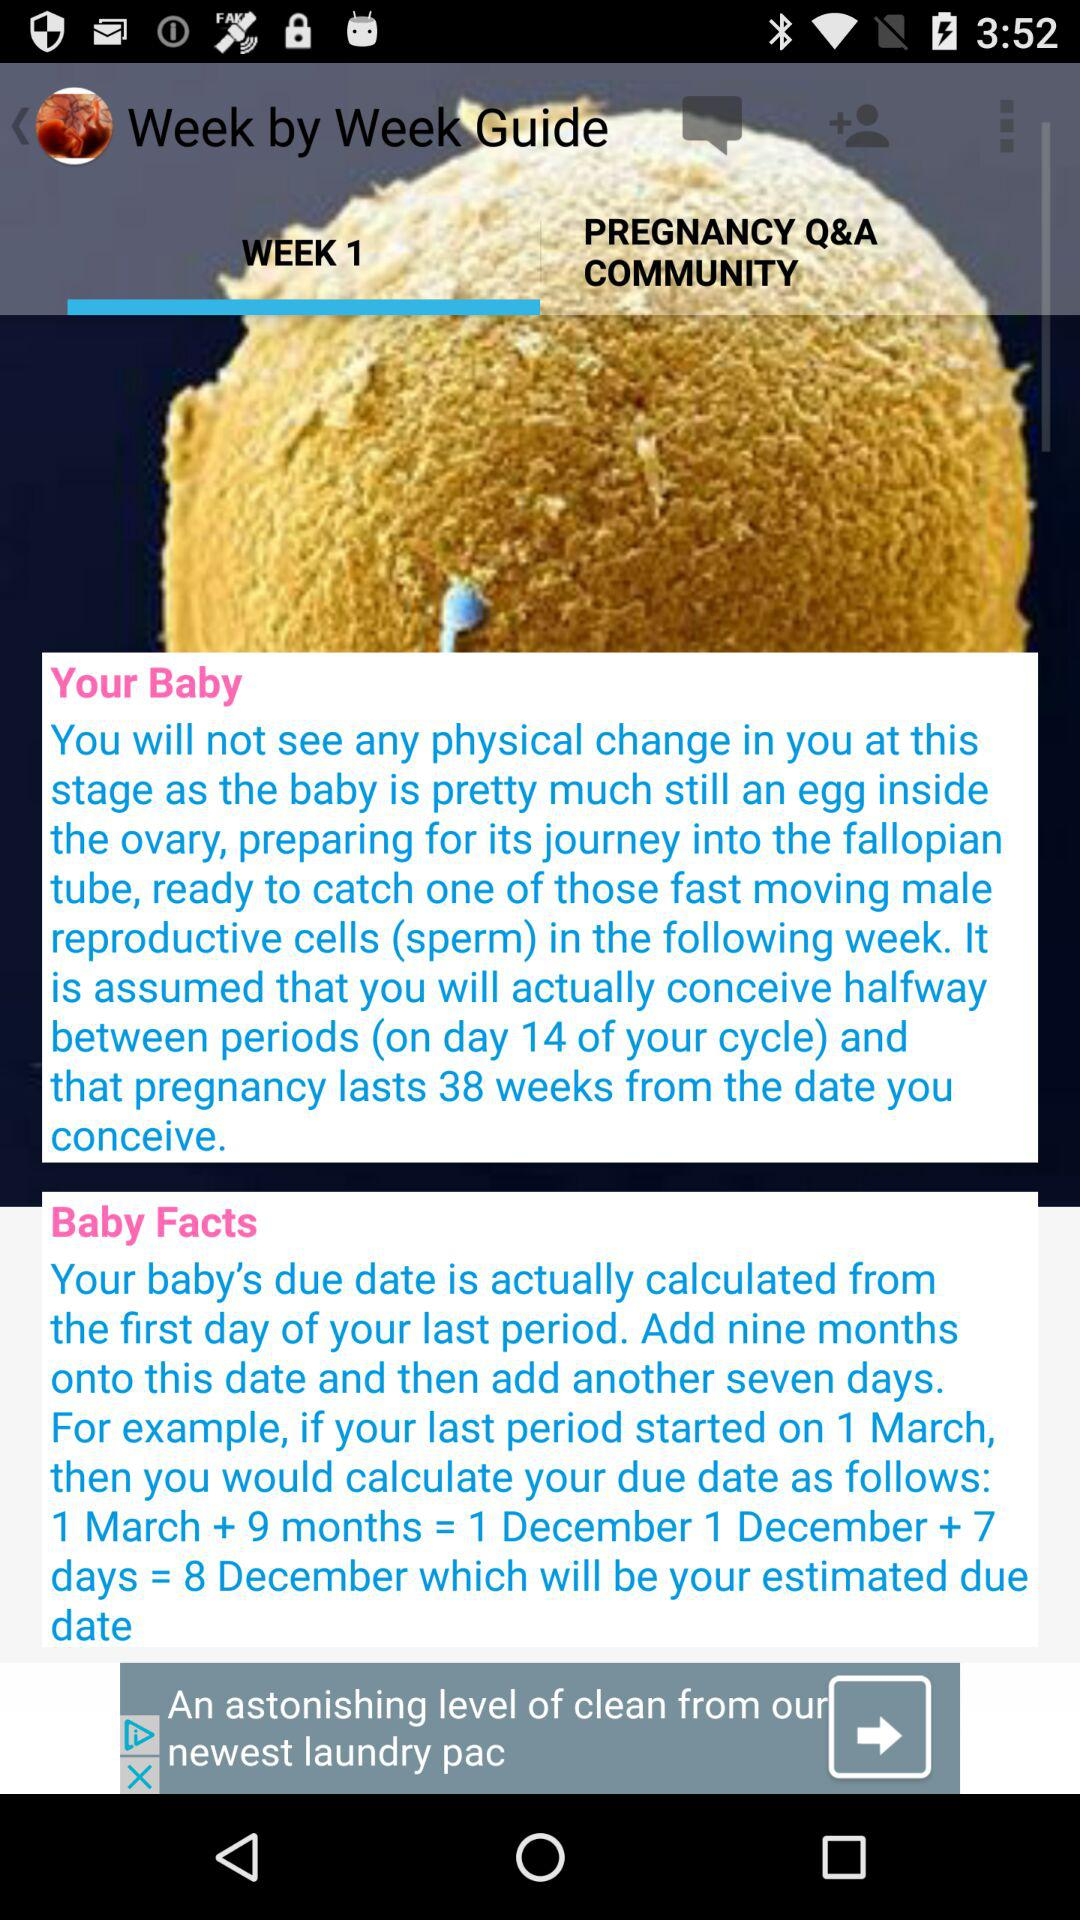Which tab is selected? The selected tab is "WEEK 1". 